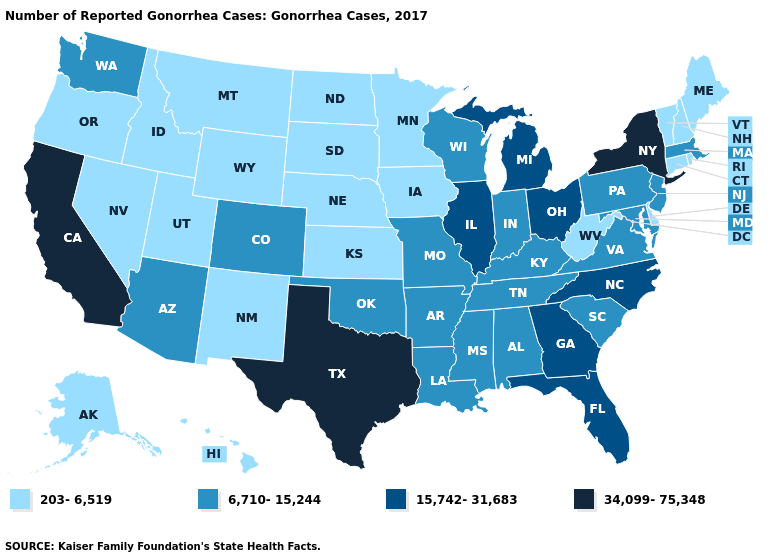Name the states that have a value in the range 15,742-31,683?
Quick response, please. Florida, Georgia, Illinois, Michigan, North Carolina, Ohio. Among the states that border New Mexico , does Arizona have the lowest value?
Write a very short answer. No. Does the first symbol in the legend represent the smallest category?
Give a very brief answer. Yes. Name the states that have a value in the range 15,742-31,683?
Answer briefly. Florida, Georgia, Illinois, Michigan, North Carolina, Ohio. Name the states that have a value in the range 15,742-31,683?
Be succinct. Florida, Georgia, Illinois, Michigan, North Carolina, Ohio. Name the states that have a value in the range 15,742-31,683?
Short answer required. Florida, Georgia, Illinois, Michigan, North Carolina, Ohio. What is the highest value in the USA?
Answer briefly. 34,099-75,348. What is the value of New Mexico?
Keep it brief. 203-6,519. Does the first symbol in the legend represent the smallest category?
Quick response, please. Yes. What is the value of Wyoming?
Write a very short answer. 203-6,519. What is the value of Colorado?
Answer briefly. 6,710-15,244. How many symbols are there in the legend?
Concise answer only. 4. Name the states that have a value in the range 15,742-31,683?
Write a very short answer. Florida, Georgia, Illinois, Michigan, North Carolina, Ohio. What is the value of Idaho?
Keep it brief. 203-6,519. What is the value of Arizona?
Quick response, please. 6,710-15,244. 